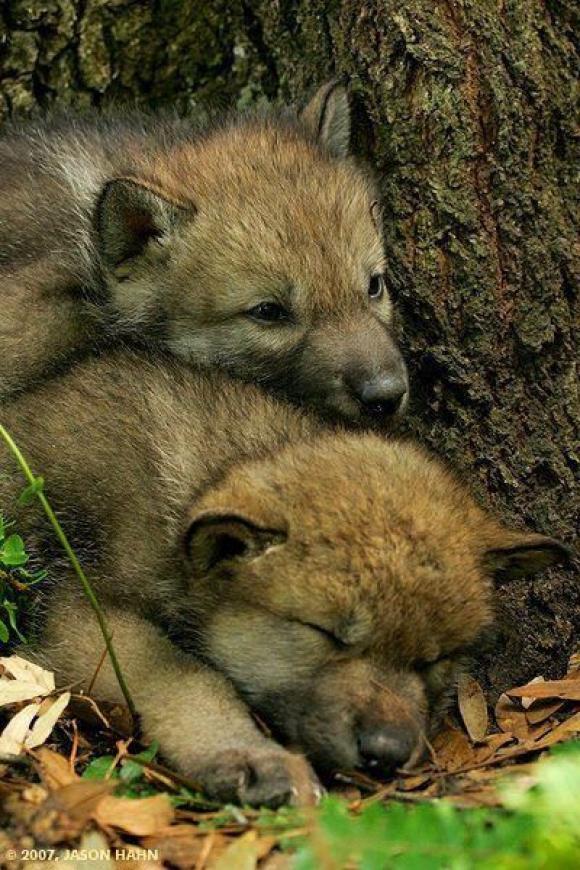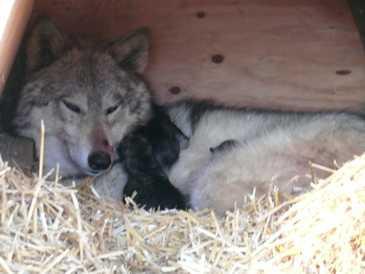The first image is the image on the left, the second image is the image on the right. Evaluate the accuracy of this statement regarding the images: "The left image contains two baby wolves laying down together.". Is it true? Answer yes or no. Yes. The first image is the image on the left, the second image is the image on the right. Evaluate the accuracy of this statement regarding the images: "The left image features a pair of wolf pups posed with one head on top of the other's head, and the right image includes an adult wolf with at least one pup.". Is it true? Answer yes or no. Yes. 